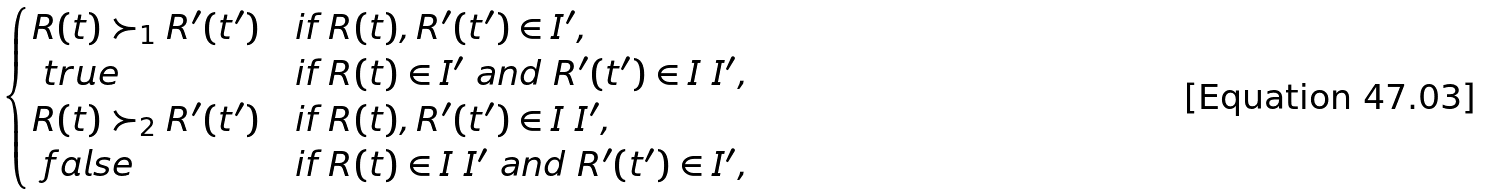Convert formula to latex. <formula><loc_0><loc_0><loc_500><loc_500>\begin{cases} R ( t ) \succ _ { 1 } R ^ { \prime } ( t ^ { \prime } ) & \text {if $R(t),R^{\prime}(t^{\prime})\in I^{\prime}$,} \\ \ t r u e & \text {if $R(t)\in I^{\prime}$ and $R^{\prime}(t^{\prime})\in I\ I^{\prime}$,} \\ R ( t ) \succ _ { 2 } R ^ { \prime } ( t ^ { \prime } ) & \text {if $R(t),R^{\prime}(t^{\prime})\in I\ I^{\prime}$,} \\ \ f a l s e & \text {if $R(t)\in I\ I^{\prime}$ and $R^{\prime}(t^{\prime})\in I^{\prime}$,} \end{cases}</formula> 